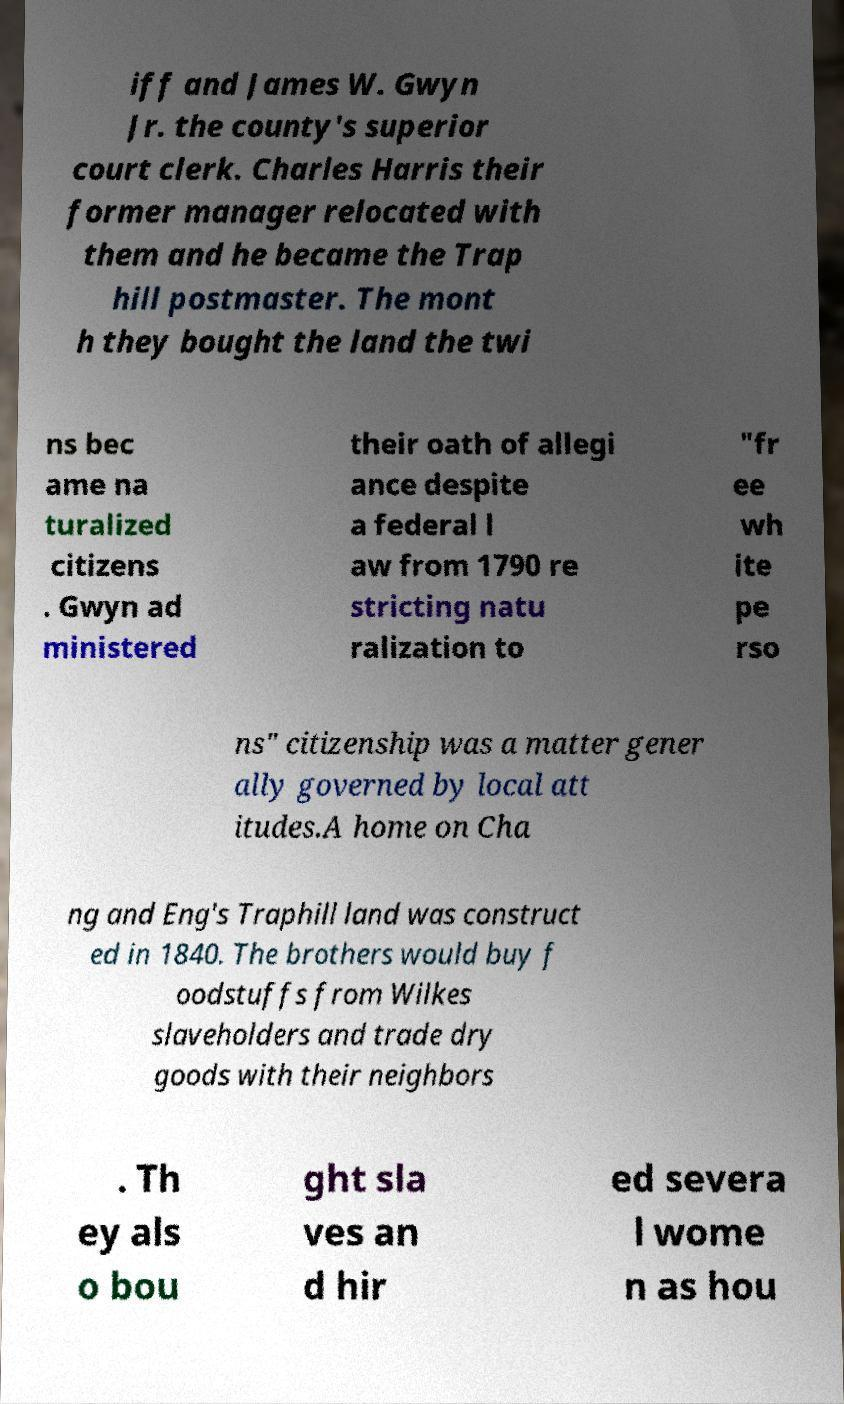Could you extract and type out the text from this image? iff and James W. Gwyn Jr. the county's superior court clerk. Charles Harris their former manager relocated with them and he became the Trap hill postmaster. The mont h they bought the land the twi ns bec ame na turalized citizens . Gwyn ad ministered their oath of allegi ance despite a federal l aw from 1790 re stricting natu ralization to "fr ee wh ite pe rso ns" citizenship was a matter gener ally governed by local att itudes.A home on Cha ng and Eng's Traphill land was construct ed in 1840. The brothers would buy f oodstuffs from Wilkes slaveholders and trade dry goods with their neighbors . Th ey als o bou ght sla ves an d hir ed severa l wome n as hou 